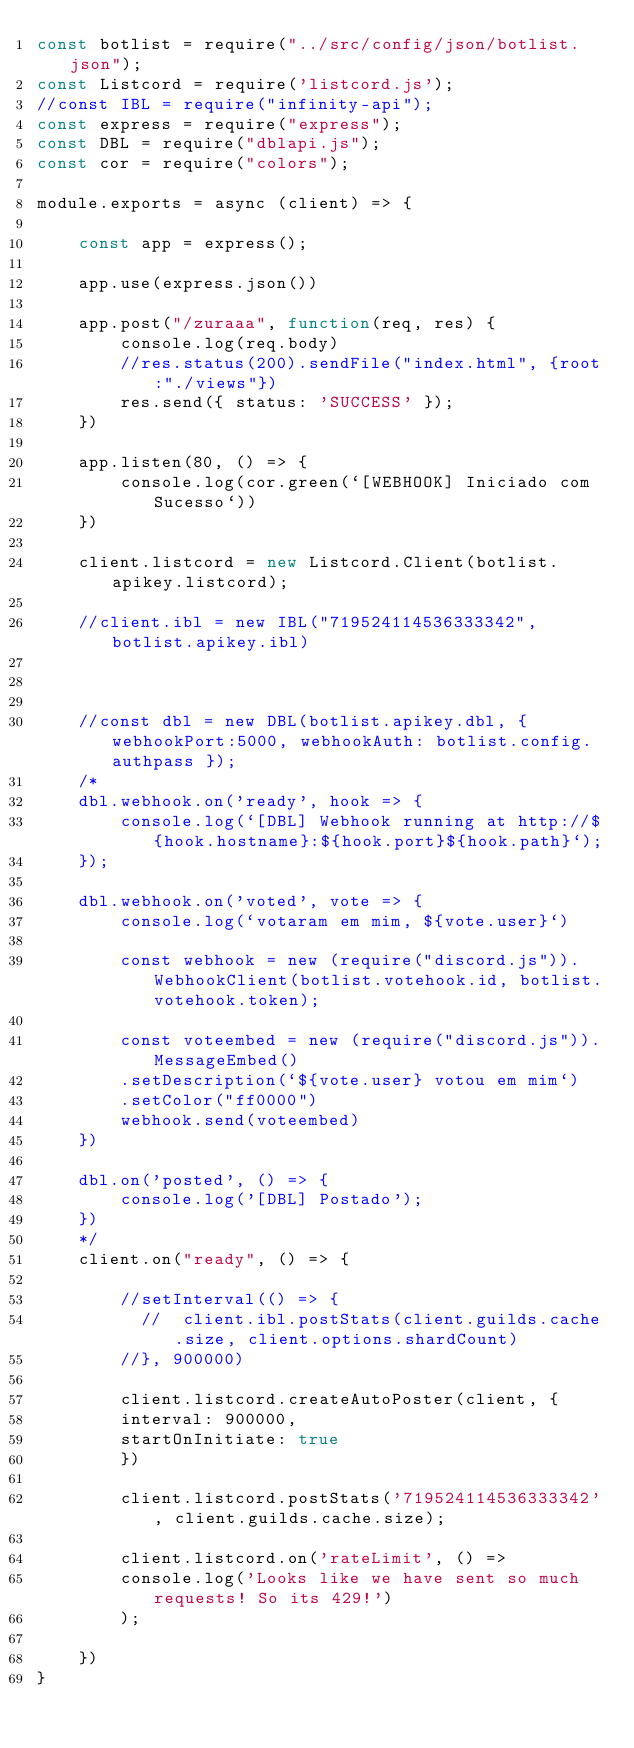Convert code to text. <code><loc_0><loc_0><loc_500><loc_500><_JavaScript_>const botlist = require("../src/config/json/botlist.json");
const Listcord = require('listcord.js');
//const IBL = require("infinity-api");
const express = require("express");
const DBL = require("dblapi.js");
const cor = require("colors");

module.exports = async (client) => {

    const app = express();

    app.use(express.json())

    app.post("/zuraaa", function(req, res) {
        console.log(req.body)
        //res.status(200).sendFile("index.html", {root:"./views"})
        res.send({ status: 'SUCCESS' });
    })

    app.listen(80, () => {
        console.log(cor.green(`[WEBHOOK] Iniciado com Sucesso`))
    })

    client.listcord = new Listcord.Client(botlist.apikey.listcord);

    //client.ibl = new IBL("719524114536333342", botlist.apikey.ibl)
    
    

    //const dbl = new DBL(botlist.apikey.dbl, { webhookPort:5000, webhookAuth: botlist.config.authpass });
    /*
    dbl.webhook.on('ready', hook => {
        console.log(`[DBL] Webhook running at http://${hook.hostname}:${hook.port}${hook.path}`);
    });

    dbl.webhook.on('voted', vote => {
        console.log(`votaram em mim, ${vote.user}`)

        const webhook = new (require("discord.js")).WebhookClient(botlist.votehook.id, botlist.votehook.token);
        
        const voteembed = new (require("discord.js")).MessageEmbed()
        .setDescription(`${vote.user} votou em mim`)
        .setColor("ff0000")
        webhook.send(voteembed)
    })

    dbl.on('posted', () => {
        console.log('[DBL] Postado');
    })
    */
    client.on("ready", () => {

        //setInterval(() => { 
          //  client.ibl.postStats(client.guilds.cache.size, client.options.shardCount)
        //}, 900000)

        client.listcord.createAutoPoster(client, {
        interval: 900000,
        startOnInitiate: true
        })

        client.listcord.postStats('719524114536333342', client.guilds.cache.size);

        client.listcord.on('rateLimit', () => 
        console.log('Looks like we have sent so much requests! So its 429!')
        );

    })
}   </code> 